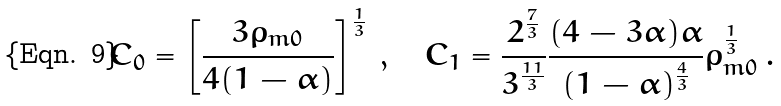<formula> <loc_0><loc_0><loc_500><loc_500>C _ { 0 } = \left [ \frac { 3 \rho _ { m 0 } } { 4 ( 1 - \alpha ) } \right ] ^ { \frac { 1 } { 3 } } \, , \quad C _ { 1 } = \frac { 2 ^ { \frac { 7 } { 3 } } } { 3 ^ { \frac { 1 1 } { 3 } } } \frac { ( 4 - 3 \alpha ) \alpha } { ( 1 - \alpha ) ^ { \frac { 4 } { 3 } } } \rho _ { m 0 } ^ { \frac { 1 } { 3 } } \, .</formula> 